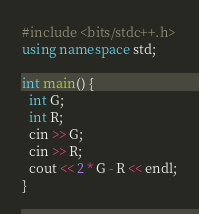<code> <loc_0><loc_0><loc_500><loc_500><_C++_>#include <bits/stdc++.h>
using namespace std;
 
int main() {
  int G;
  int R;
  cin >> G;
  cin >> R;
  cout << 2 * G - R << endl;
}</code> 